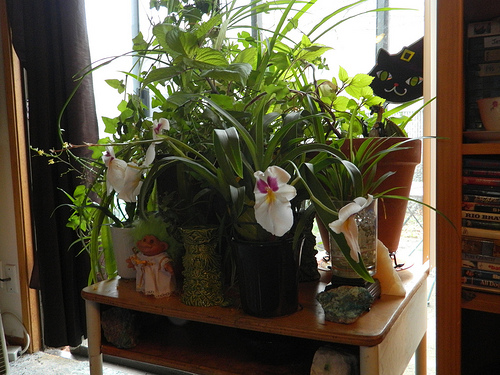<image>
Is the power strip on the table? No. The power strip is not positioned on the table. They may be near each other, but the power strip is not supported by or resting on top of the table. 